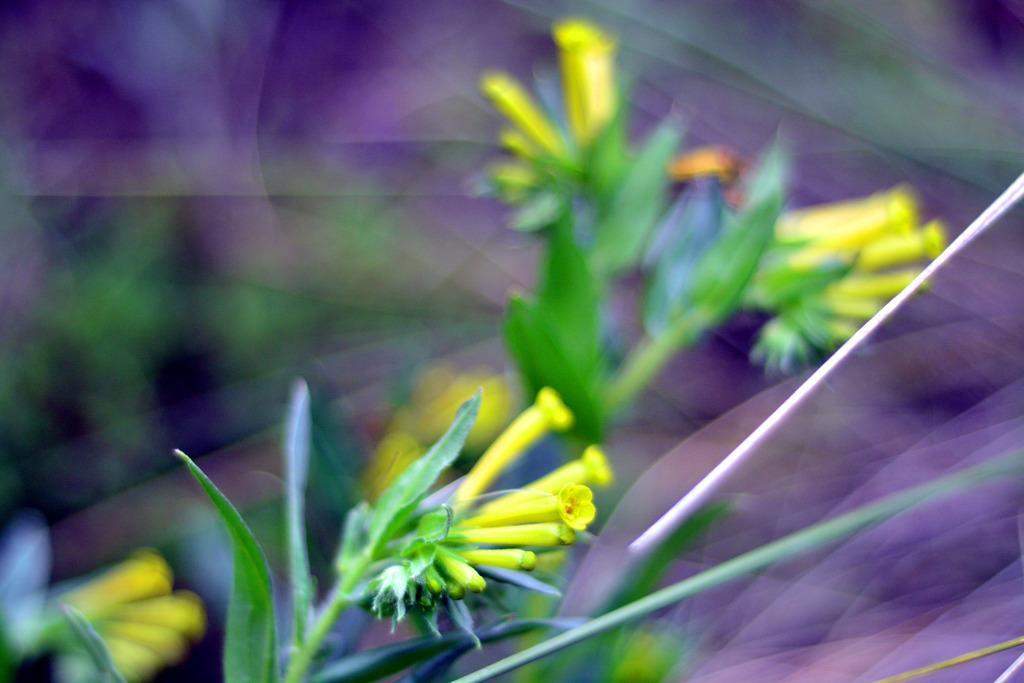In one or two sentences, can you explain what this image depicts? In this picture I can observe some flower buds to the plants. I can observe green color leaves to the plants. In the background I can observe violet color. 